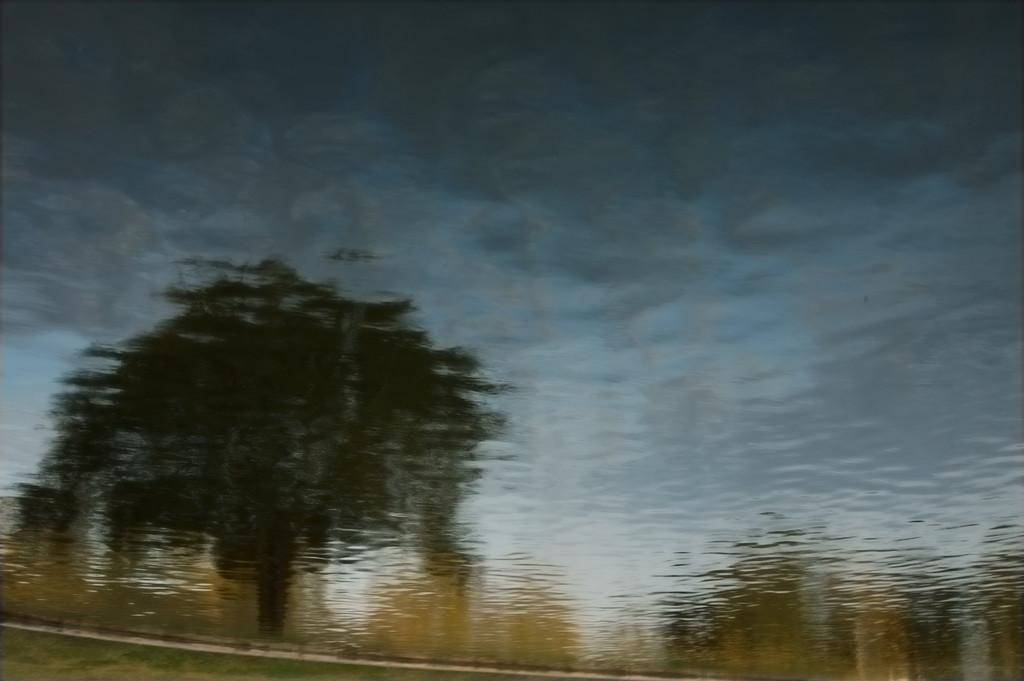What type of vegetation can be seen in the image? There is a tree and plants in the image. What is visible at the top of the image? The sky is visible at the top of the image. Can you describe the quality of the image? The image is blurry. What type of sign can be seen in the image? There is no sign present in the image; it features a tree, plants, and the sky. What is the fifth item in the image? The image only contains a tree, plants, and the sky, so there is no fifth item. 